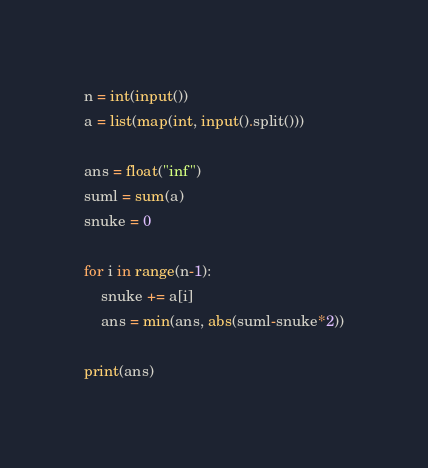Convert code to text. <code><loc_0><loc_0><loc_500><loc_500><_Python_>n = int(input())
a = list(map(int, input().split()))

ans = float("inf")
suml = sum(a)
snuke = 0

for i in range(n-1):
    snuke += a[i]
    ans = min(ans, abs(suml-snuke*2))

print(ans)</code> 